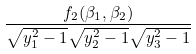<formula> <loc_0><loc_0><loc_500><loc_500>\frac { f _ { 2 } ( \beta _ { 1 } , \beta _ { 2 } ) } { \sqrt { y _ { 1 } ^ { 2 } - 1 } \sqrt { y _ { 2 } ^ { 2 } - 1 } \sqrt { y _ { 3 } ^ { 2 } - 1 } }</formula> 